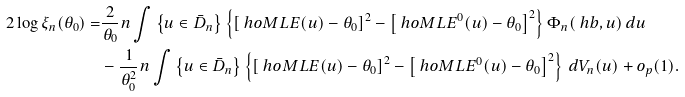Convert formula to latex. <formula><loc_0><loc_0><loc_500><loc_500>2 \log \xi _ { n } ( \theta _ { 0 } ) = & \frac { 2 } { \theta _ { 0 } } n \int \left \{ u \in \bar { D } _ { n } \right \} \left \{ \left [ \ h o M L E ( u ) - \theta _ { 0 } \right ] ^ { 2 } - \left [ \ h o M L E ^ { 0 } ( u ) - \theta _ { 0 } \right ] ^ { 2 } \right \} \Phi _ { n } ( \ h b , u ) \, d u \\ & - \frac { 1 } { \theta _ { 0 } ^ { 2 } } n \int \left \{ u \in \bar { D } _ { n } \right \} \left \{ \left [ \ h o M L E ( u ) - \theta _ { 0 } \right ] ^ { 2 } - \left [ \ h o M L E ^ { 0 } ( u ) - \theta _ { 0 } \right ] ^ { 2 } \right \} \, d V _ { n } ( u ) + o _ { p } ( 1 ) .</formula> 